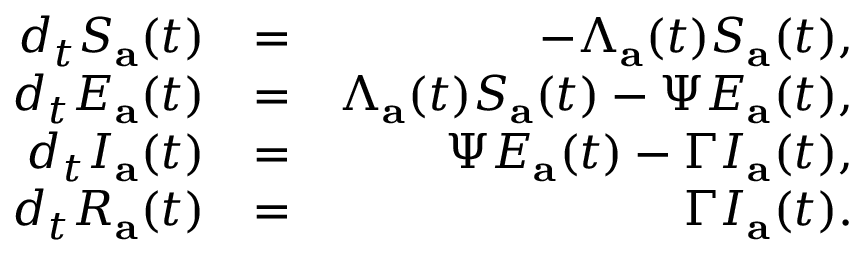<formula> <loc_0><loc_0><loc_500><loc_500>\begin{array} { r l r } { d _ { t } S _ { a } ( t ) } & { = } & { - \Lambda _ { a } ( t ) S _ { a } ( t ) , } \\ { d _ { t } E _ { a } ( t ) } & { = } & { \Lambda _ { a } ( t ) S _ { a } ( t ) - \Psi E _ { a } ( t ) , } \\ { d _ { t } I _ { a } ( t ) } & { = } & { \Psi E _ { a } ( t ) - \Gamma I _ { a } ( t ) , } \\ { d _ { t } R _ { a } ( t ) } & { = } & { \Gamma I _ { a } ( t ) . } \end{array}</formula> 